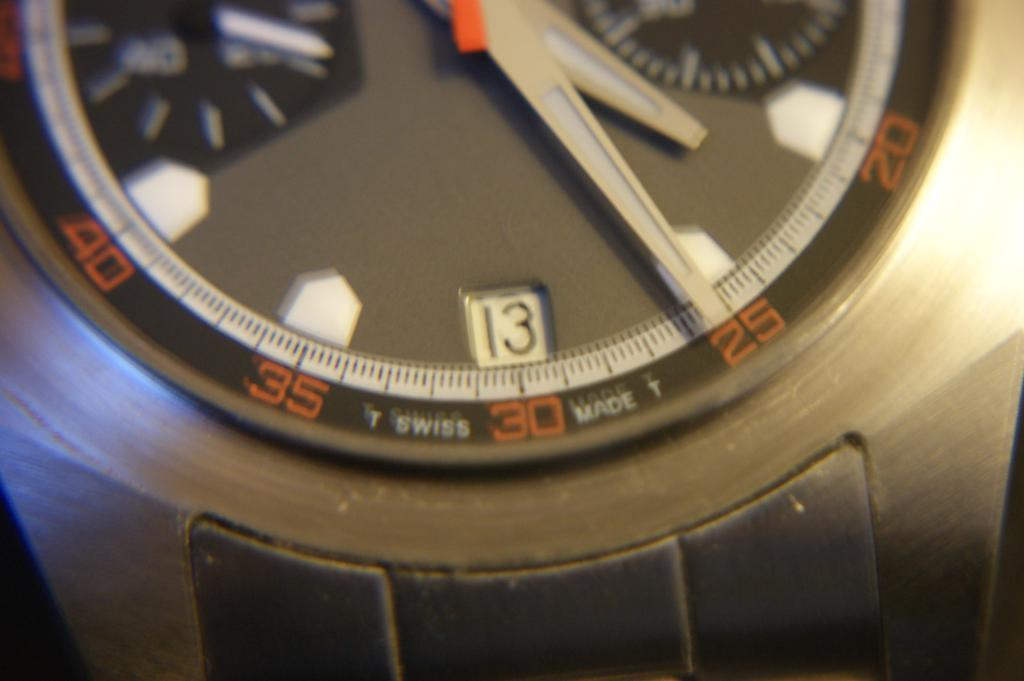<image>
Offer a succinct explanation of the picture presented. The rim of a watch has the words SWISS MADE on it. 